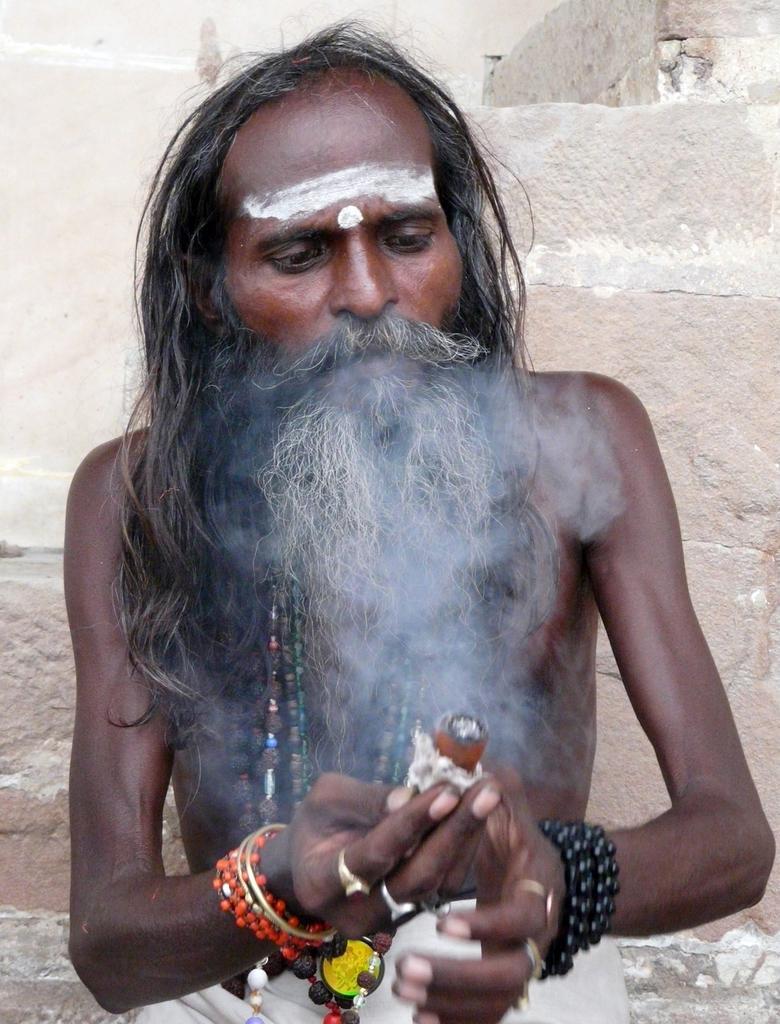Please provide a concise description of this image. In this picture we can see a person with the beard and the person is holding an object. Behind the person there is the wall. 